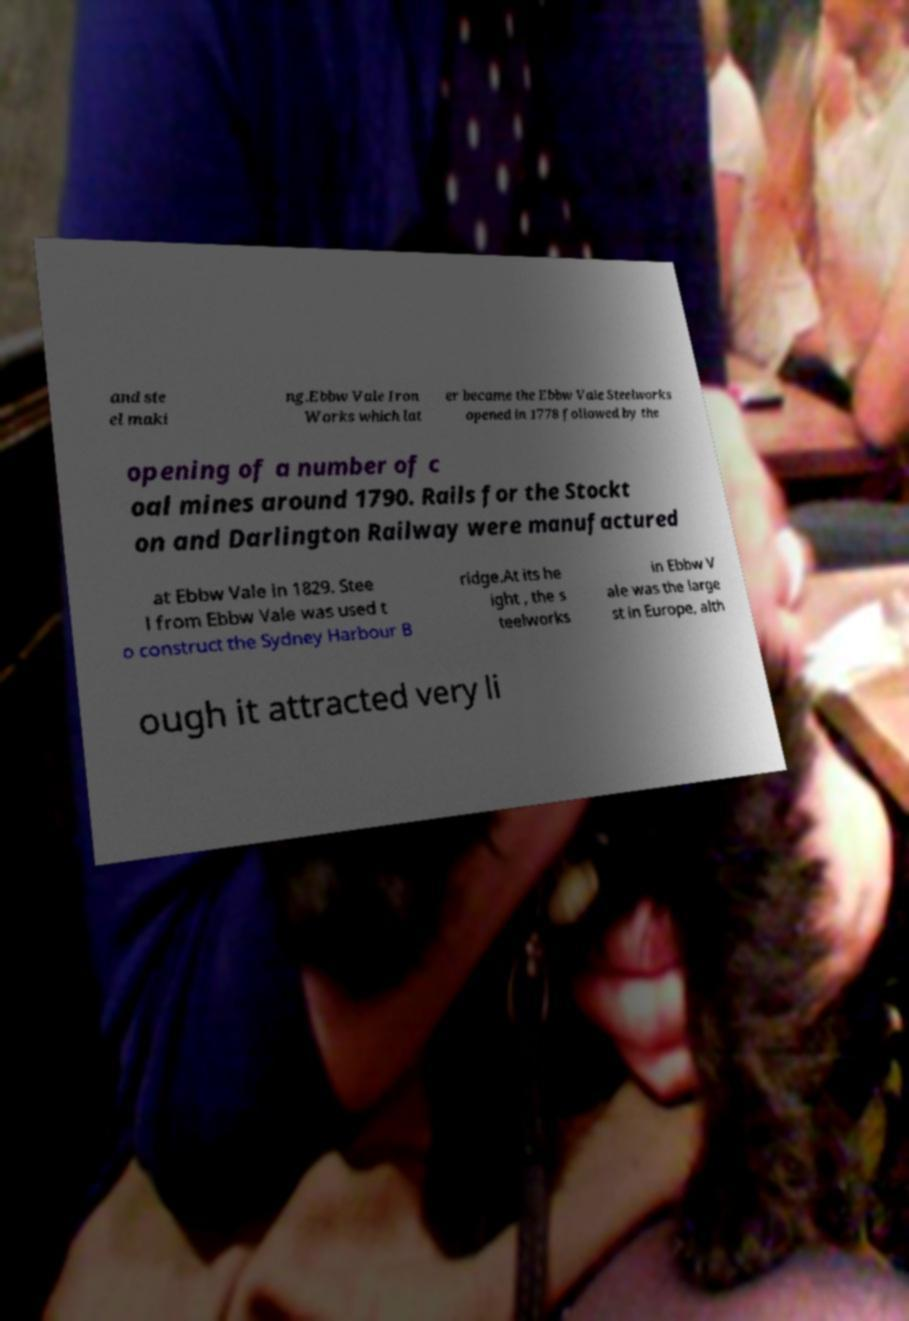I need the written content from this picture converted into text. Can you do that? and ste el maki ng.Ebbw Vale Iron Works which lat er became the Ebbw Vale Steelworks opened in 1778 followed by the opening of a number of c oal mines around 1790. Rails for the Stockt on and Darlington Railway were manufactured at Ebbw Vale in 1829. Stee l from Ebbw Vale was used t o construct the Sydney Harbour B ridge.At its he ight , the s teelworks in Ebbw V ale was the large st in Europe, alth ough it attracted very li 